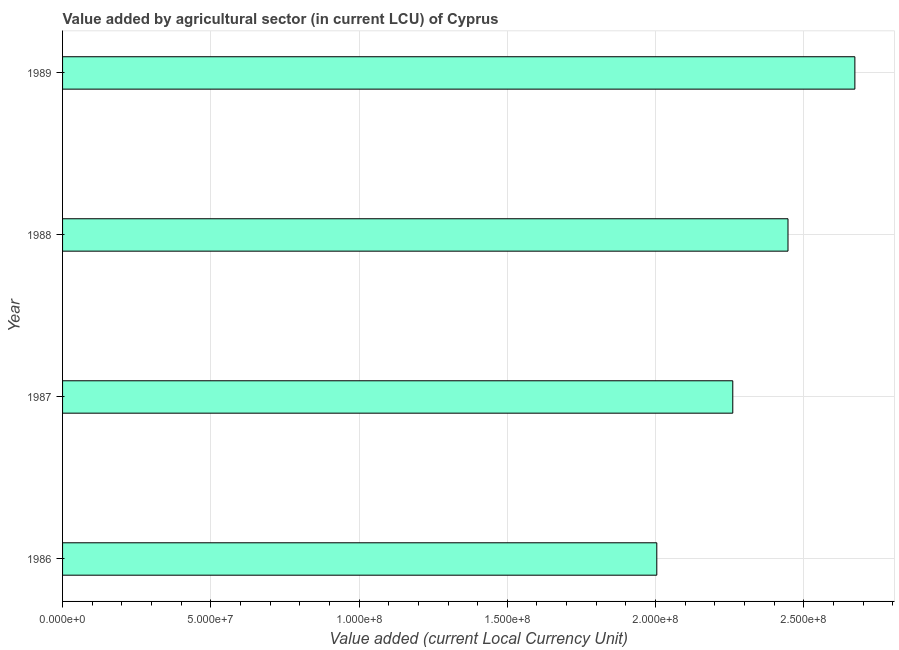What is the title of the graph?
Keep it short and to the point. Value added by agricultural sector (in current LCU) of Cyprus. What is the label or title of the X-axis?
Give a very brief answer. Value added (current Local Currency Unit). What is the value added by agriculture sector in 1987?
Keep it short and to the point. 2.26e+08. Across all years, what is the maximum value added by agriculture sector?
Offer a very short reply. 2.67e+08. Across all years, what is the minimum value added by agriculture sector?
Offer a very short reply. 2.00e+08. What is the sum of the value added by agriculture sector?
Your answer should be compact. 9.38e+08. What is the difference between the value added by agriculture sector in 1986 and 1987?
Your answer should be compact. -2.56e+07. What is the average value added by agriculture sector per year?
Provide a succinct answer. 2.35e+08. What is the median value added by agriculture sector?
Keep it short and to the point. 2.35e+08. In how many years, is the value added by agriculture sector greater than 220000000 LCU?
Your response must be concise. 3. Do a majority of the years between 1987 and 1989 (inclusive) have value added by agriculture sector greater than 50000000 LCU?
Your answer should be very brief. Yes. What is the ratio of the value added by agriculture sector in 1987 to that in 1989?
Ensure brevity in your answer.  0.85. Is the value added by agriculture sector in 1987 less than that in 1989?
Offer a terse response. Yes. What is the difference between the highest and the second highest value added by agriculture sector?
Offer a very short reply. 2.26e+07. What is the difference between the highest and the lowest value added by agriculture sector?
Give a very brief answer. 6.68e+07. How many bars are there?
Provide a short and direct response. 4. Are all the bars in the graph horizontal?
Give a very brief answer. Yes. How many years are there in the graph?
Offer a very short reply. 4. What is the difference between two consecutive major ticks on the X-axis?
Offer a terse response. 5.00e+07. Are the values on the major ticks of X-axis written in scientific E-notation?
Make the answer very short. Yes. What is the Value added (current Local Currency Unit) in 1986?
Your answer should be very brief. 2.00e+08. What is the Value added (current Local Currency Unit) in 1987?
Provide a succinct answer. 2.26e+08. What is the Value added (current Local Currency Unit) of 1988?
Keep it short and to the point. 2.45e+08. What is the Value added (current Local Currency Unit) in 1989?
Your answer should be very brief. 2.67e+08. What is the difference between the Value added (current Local Currency Unit) in 1986 and 1987?
Ensure brevity in your answer.  -2.56e+07. What is the difference between the Value added (current Local Currency Unit) in 1986 and 1988?
Your answer should be compact. -4.43e+07. What is the difference between the Value added (current Local Currency Unit) in 1986 and 1989?
Ensure brevity in your answer.  -6.68e+07. What is the difference between the Value added (current Local Currency Unit) in 1987 and 1988?
Keep it short and to the point. -1.86e+07. What is the difference between the Value added (current Local Currency Unit) in 1987 and 1989?
Make the answer very short. -4.12e+07. What is the difference between the Value added (current Local Currency Unit) in 1988 and 1989?
Ensure brevity in your answer.  -2.26e+07. What is the ratio of the Value added (current Local Currency Unit) in 1986 to that in 1987?
Keep it short and to the point. 0.89. What is the ratio of the Value added (current Local Currency Unit) in 1986 to that in 1988?
Provide a succinct answer. 0.82. What is the ratio of the Value added (current Local Currency Unit) in 1987 to that in 1988?
Your answer should be compact. 0.92. What is the ratio of the Value added (current Local Currency Unit) in 1987 to that in 1989?
Offer a very short reply. 0.85. What is the ratio of the Value added (current Local Currency Unit) in 1988 to that in 1989?
Your answer should be compact. 0.92. 